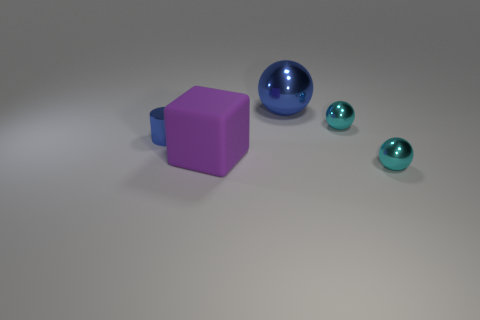Add 4 balls. How many objects exist? 9 Subtract all cylinders. How many objects are left? 4 Add 2 blocks. How many blocks exist? 3 Subtract 0 green blocks. How many objects are left? 5 Subtract all small cyan matte objects. Subtract all large blue shiny objects. How many objects are left? 4 Add 2 blue things. How many blue things are left? 4 